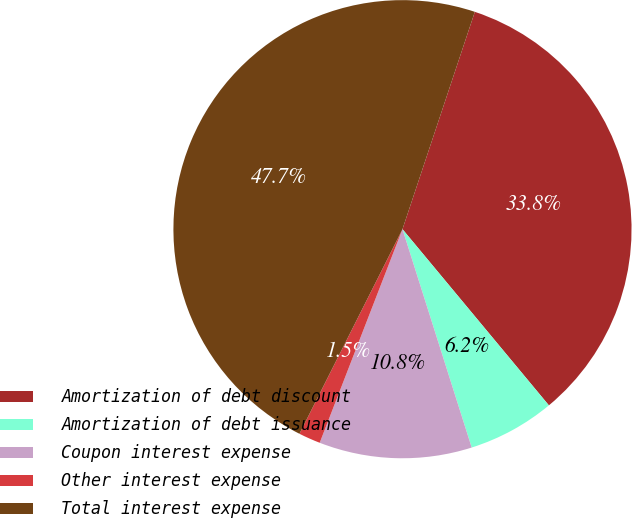<chart> <loc_0><loc_0><loc_500><loc_500><pie_chart><fcel>Amortization of debt discount<fcel>Amortization of debt issuance<fcel>Coupon interest expense<fcel>Other interest expense<fcel>Total interest expense<nl><fcel>33.85%<fcel>6.15%<fcel>10.77%<fcel>1.54%<fcel>47.69%<nl></chart> 